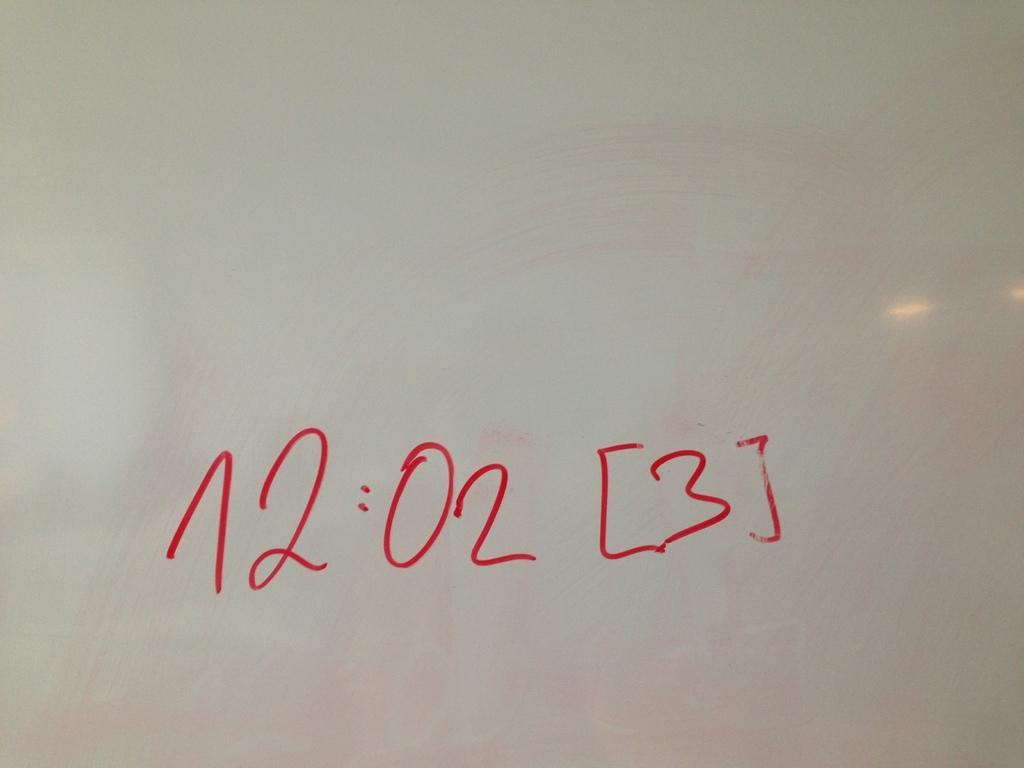<image>
Relay a brief, clear account of the picture shown. A dry erase board says 12:02 in red ink. 